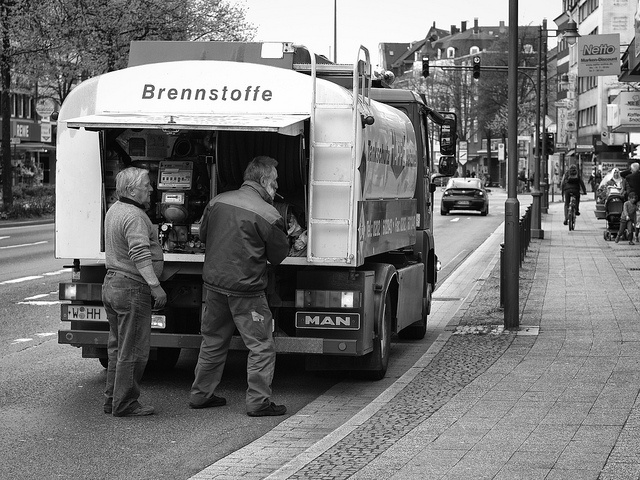Describe the objects in this image and their specific colors. I can see truck in black, lightgray, gray, and darkgray tones, people in gray and black tones, people in black, gray, darkgray, and lightgray tones, car in black, gray, lightgray, and darkgray tones, and people in black, gray, and lightgray tones in this image. 